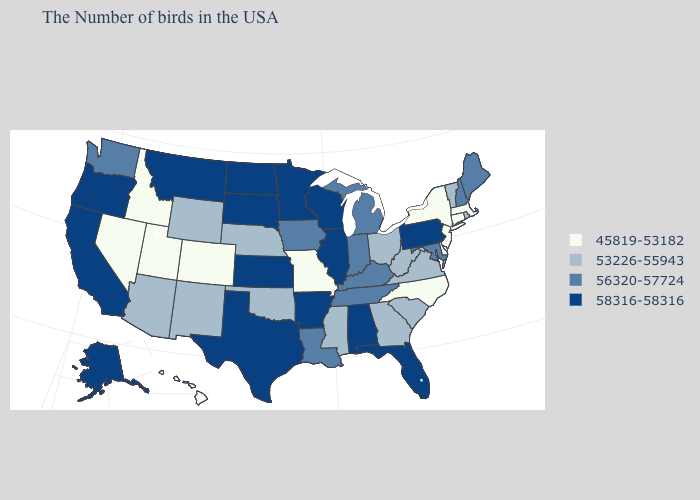Among the states that border Minnesota , does Iowa have the highest value?
Short answer required. No. What is the value of Idaho?
Concise answer only. 45819-53182. Name the states that have a value in the range 45819-53182?
Write a very short answer. Massachusetts, Connecticut, New York, New Jersey, Delaware, North Carolina, Missouri, Colorado, Utah, Idaho, Nevada, Hawaii. Name the states that have a value in the range 58316-58316?
Concise answer only. Pennsylvania, Florida, Alabama, Wisconsin, Illinois, Arkansas, Minnesota, Kansas, Texas, South Dakota, North Dakota, Montana, California, Oregon, Alaska. What is the value of Connecticut?
Write a very short answer. 45819-53182. Name the states that have a value in the range 56320-57724?
Short answer required. Maine, New Hampshire, Maryland, Michigan, Kentucky, Indiana, Tennessee, Louisiana, Iowa, Washington. What is the lowest value in states that border New York?
Keep it brief. 45819-53182. Name the states that have a value in the range 56320-57724?
Concise answer only. Maine, New Hampshire, Maryland, Michigan, Kentucky, Indiana, Tennessee, Louisiana, Iowa, Washington. Does Georgia have a lower value than Virginia?
Be succinct. No. Among the states that border South Carolina , does North Carolina have the lowest value?
Keep it brief. Yes. Does New York have the highest value in the USA?
Quick response, please. No. How many symbols are there in the legend?
Give a very brief answer. 4. Does the first symbol in the legend represent the smallest category?
Quick response, please. Yes. Does Washington have the same value as Louisiana?
Answer briefly. Yes. Does North Dakota have the highest value in the MidWest?
Concise answer only. Yes. 